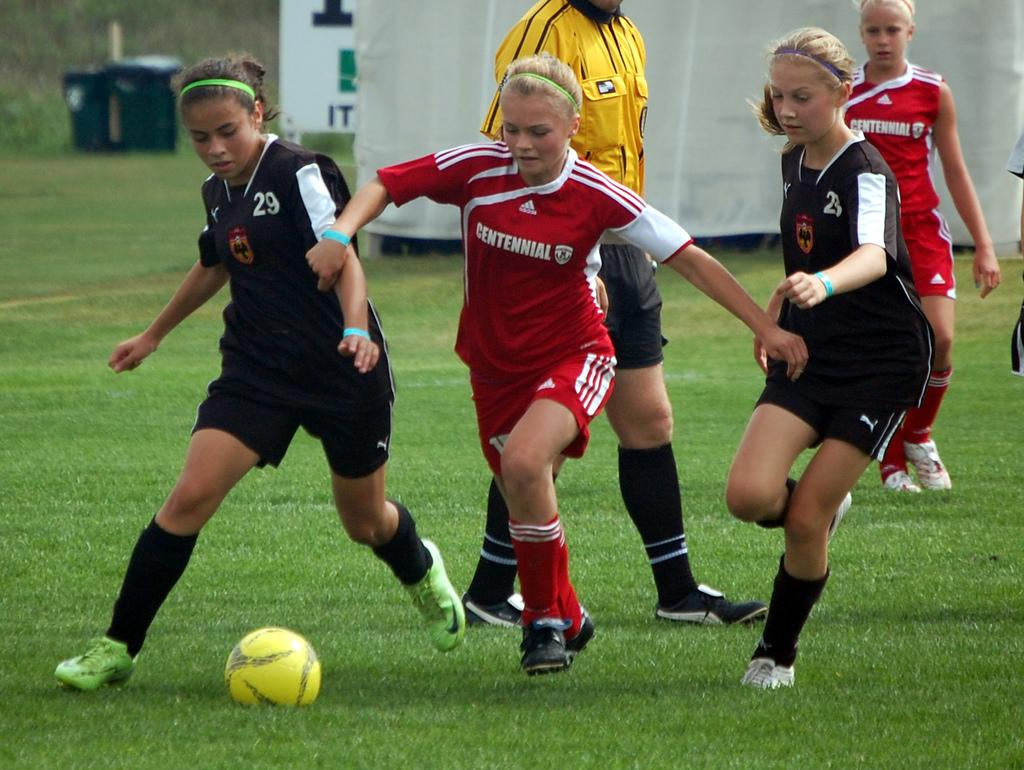<image>
Create a compact narrative representing the image presented. Players from one soccer team wear Adidas uniforms, while the others wear Puma uniforms. 